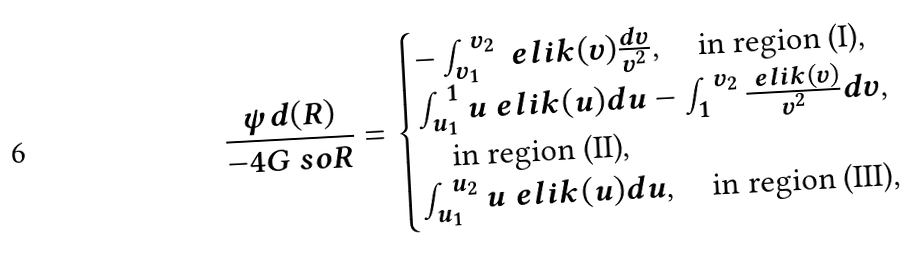Convert formula to latex. <formula><loc_0><loc_0><loc_500><loc_500>\frac { \psi d ( R ) } { - 4 G \ s o R } = \begin{cases} - \int _ { v _ { 1 } } ^ { v _ { 2 } } { \ e l i k ( v ) \frac { d v } { v ^ { 2 } } } , \quad \text {in region (I)} , \\ \int _ { u _ { 1 } } ^ { 1 } { u \ e l i k ( u ) d u } - \int _ { 1 } ^ { v _ { 2 } } { \frac { \ e l i k ( v ) } { v ^ { 2 } } d v } , \\ \quad \text {in region (II)} , \\ \int _ { u _ { 1 } } ^ { u _ { 2 } } { u \ e l i k ( u ) d u } , \quad \text {in region (III)} , \end{cases}</formula> 